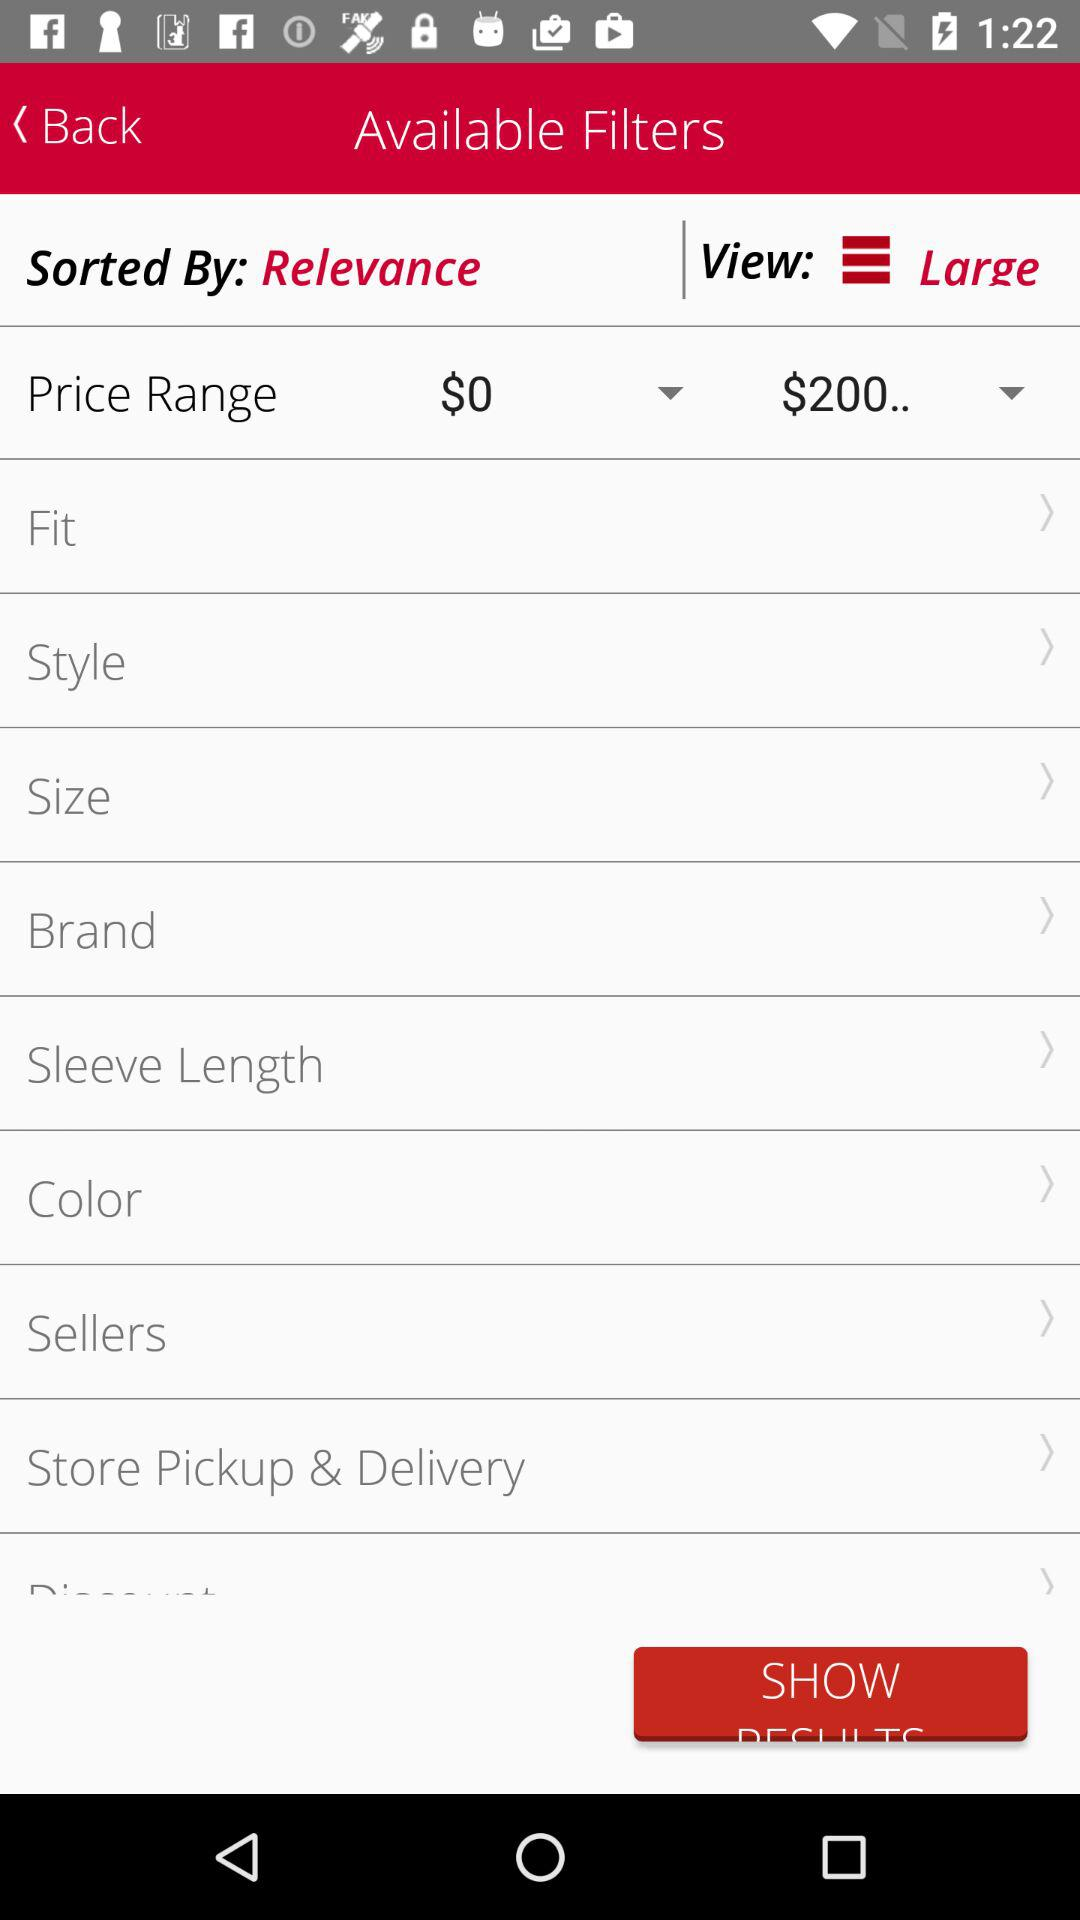Which colors are available for selection?
When the provided information is insufficient, respond with <no answer>. <no answer> 